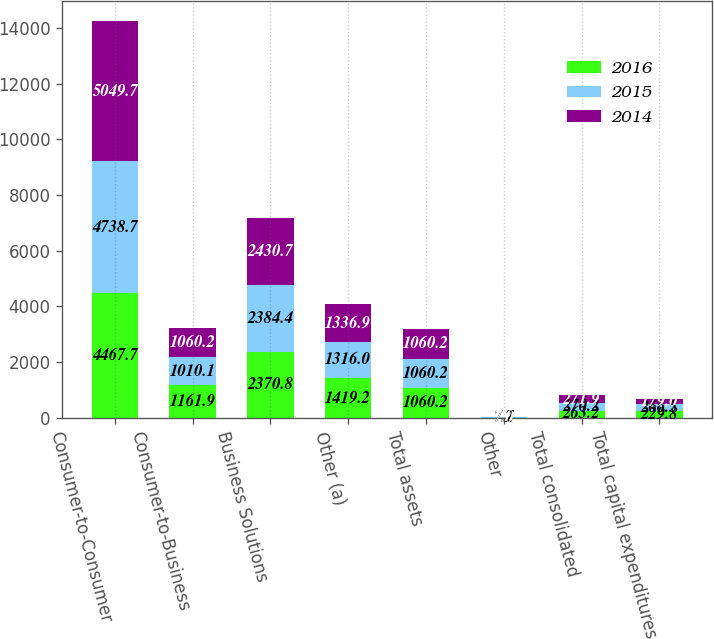Convert chart. <chart><loc_0><loc_0><loc_500><loc_500><stacked_bar_chart><ecel><fcel>Consumer-to-Consumer<fcel>Consumer-to-Business<fcel>Business Solutions<fcel>Other (a)<fcel>Total assets<fcel>Other<fcel>Total consolidated<fcel>Total capital expenditures<nl><fcel>2016<fcel>4467.7<fcel>1161.9<fcel>2370.8<fcel>1419.2<fcel>1060.2<fcel>7.2<fcel>263.2<fcel>229.8<nl><fcel>2015<fcel>4738.7<fcel>1010.1<fcel>2384.4<fcel>1316<fcel>1060.2<fcel>7.7<fcel>270.2<fcel>266.5<nl><fcel>2014<fcel>5049.7<fcel>1060.2<fcel>2430.7<fcel>1336.9<fcel>1060.2<fcel>7<fcel>271.9<fcel>179<nl></chart> 